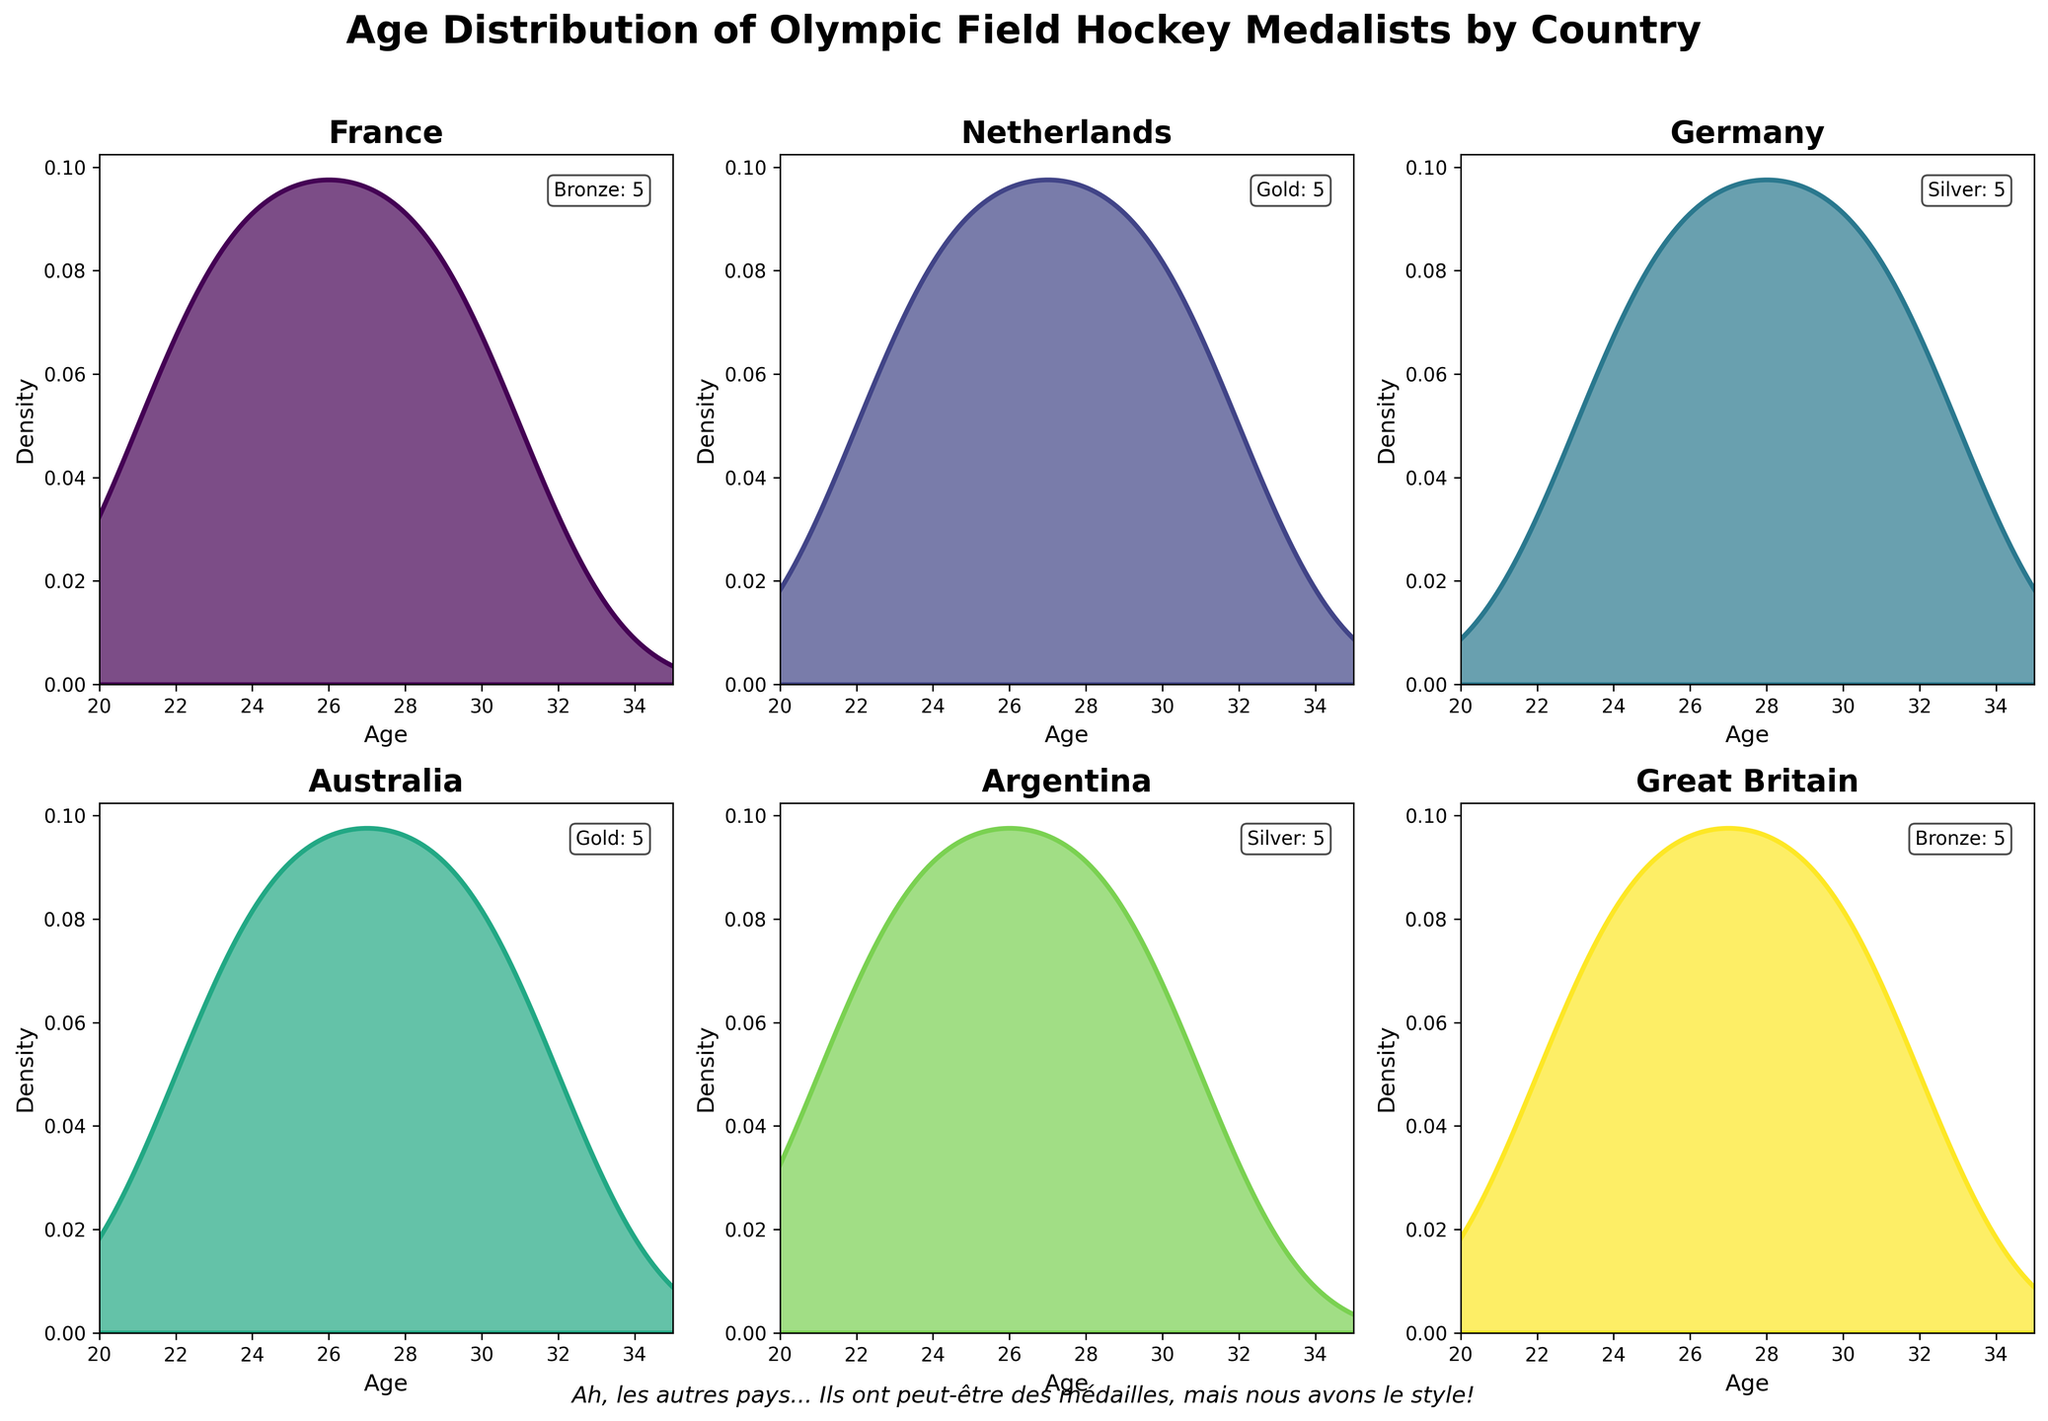Which country has the highest peak in its age density plot? Look at the density peaks for all countries and identify the highest one. The Netherlands has the highest peak, indicating a higher concentration of ages.
Answer: The Netherlands What is the age range covered in the plots for all countries? Note the x-axis limits of the density plots, which are consistent for all countries. The range from 20 to 35 is covered in the plots.
Answer: 20 to 35 Which country has the widest spread in the age distribution of its medalists? Look for the country whose density plot is the most spread out, indicating a wider age range. Germany's density plot is the most spread out, indicating its wider age range of medalists.
Answer: Germany How does the age distribution of medalists from France compare to that of Great Britain? Compare the density plots of France and Great Britain for characteristics like peak locations and spread. Both France and Great Britain have similar spread, but Great Britain's peak is slightly younger.
Answer: Similar, Great Britain's peak is younger Which country predominantly has older medalists, Argentina or Australia? Compare the position of the density peaks of both countries on the age axis. Australia's density peak is higher at older ages compared to Argentina.
Answer: Australia Are there more gold medalists or silver medalists from the Netherlands? Refer to the medal counts in the Netherlands plot's annotation. The annotation shows the number of gold medals explicitly.
Answer: Gold medalists Do France and Argentina have similar age distributions for their medalists? Compare the density plots of France and Argentina by looking at their shapes and peak locations. Both countries have similar shaped plots but with slightly different peak locations.
Answer: Similar Is the peak age of medalists from Germany higher than that of Great Britain? Compare the location of the peaks in the density plots of Germany and Great Britain. The peak age of medalists from Germany is slightly higher than Great Britain's peak age.
Answer: Yes Which country has medalists mainly concentrated around ages 23-25? Identify the country with a significant peak between ages 23-25. France shows a peak in this range.
Answer: France 